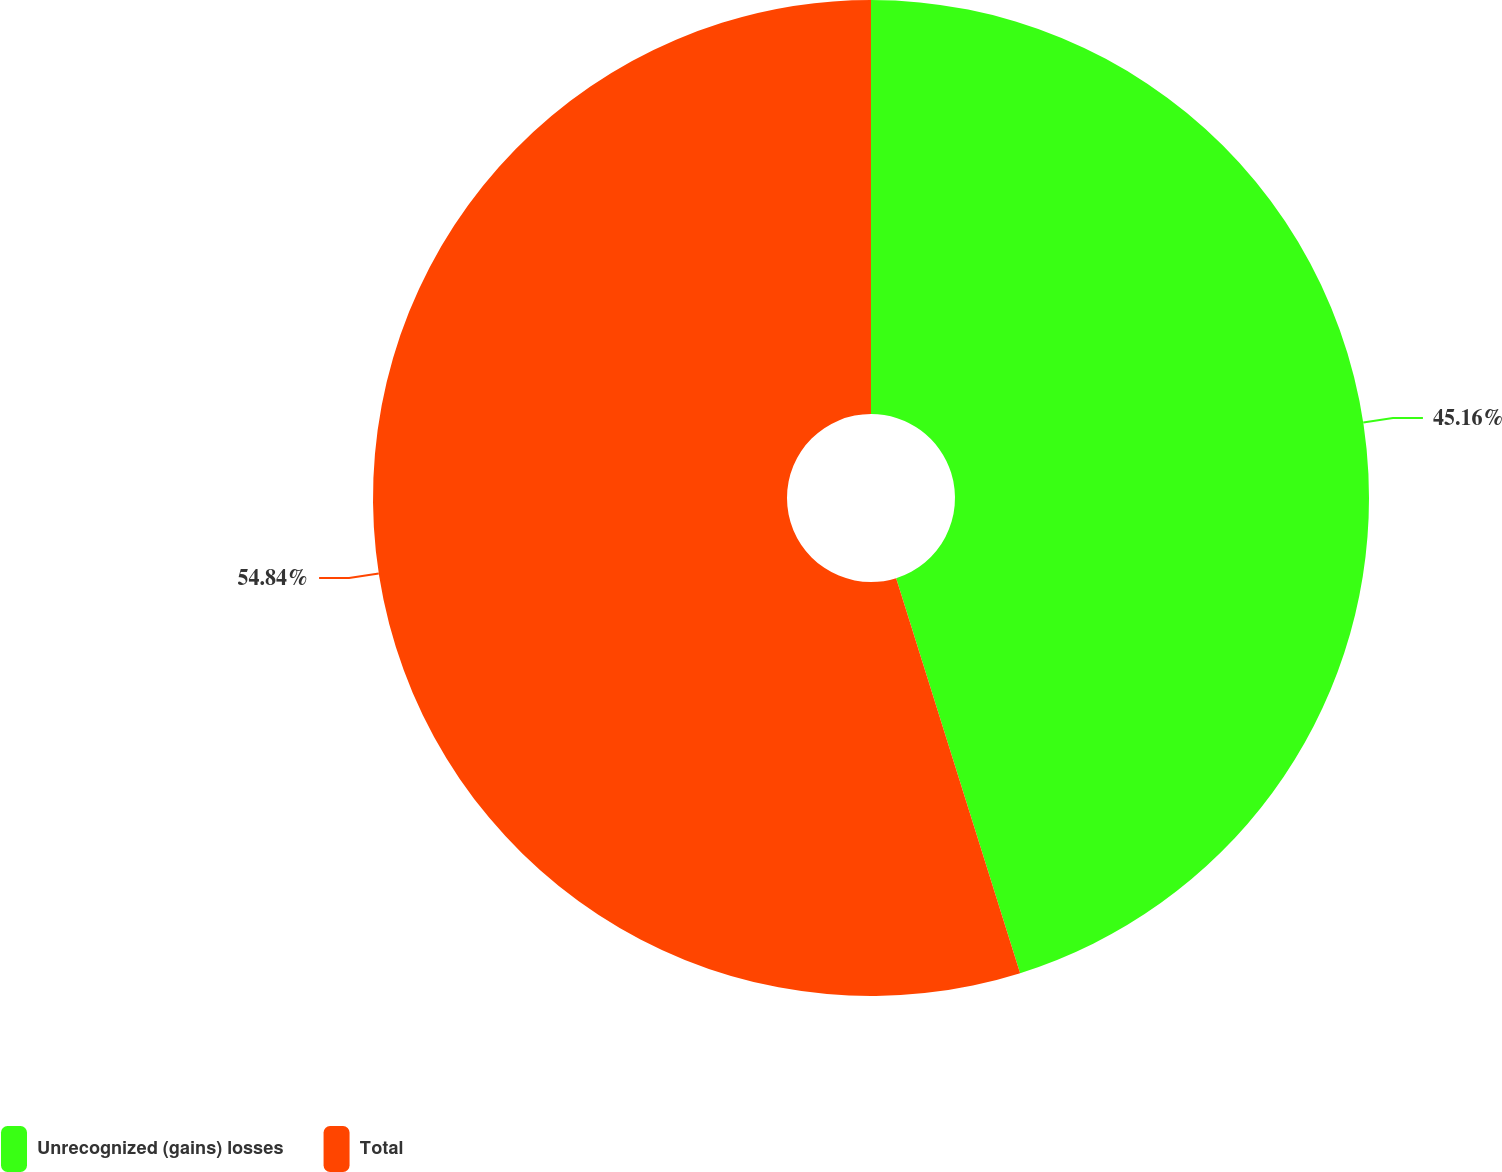Convert chart to OTSL. <chart><loc_0><loc_0><loc_500><loc_500><pie_chart><fcel>Unrecognized (gains) losses<fcel>Total<nl><fcel>45.16%<fcel>54.84%<nl></chart> 